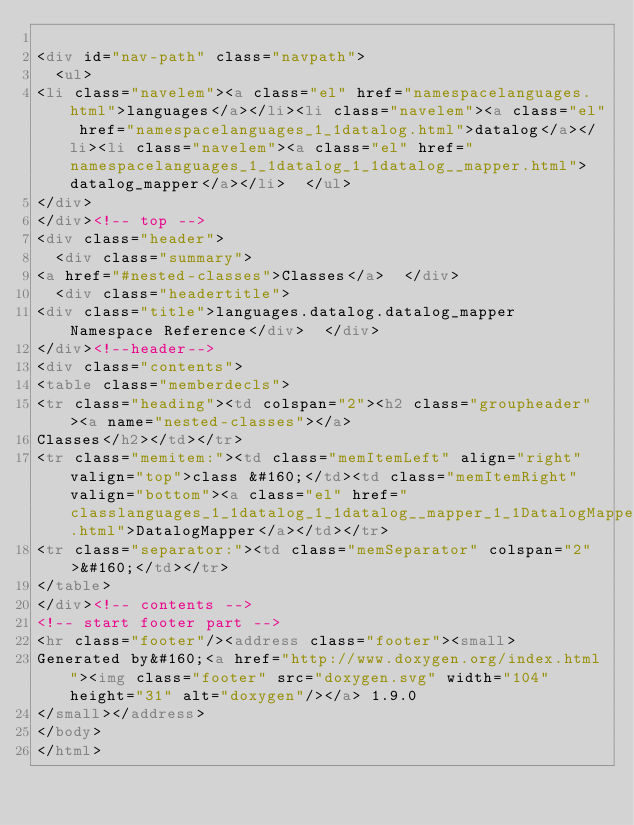<code> <loc_0><loc_0><loc_500><loc_500><_HTML_>
<div id="nav-path" class="navpath">
  <ul>
<li class="navelem"><a class="el" href="namespacelanguages.html">languages</a></li><li class="navelem"><a class="el" href="namespacelanguages_1_1datalog.html">datalog</a></li><li class="navelem"><a class="el" href="namespacelanguages_1_1datalog_1_1datalog__mapper.html">datalog_mapper</a></li>  </ul>
</div>
</div><!-- top -->
<div class="header">
  <div class="summary">
<a href="#nested-classes">Classes</a>  </div>
  <div class="headertitle">
<div class="title">languages.datalog.datalog_mapper Namespace Reference</div>  </div>
</div><!--header-->
<div class="contents">
<table class="memberdecls">
<tr class="heading"><td colspan="2"><h2 class="groupheader"><a name="nested-classes"></a>
Classes</h2></td></tr>
<tr class="memitem:"><td class="memItemLeft" align="right" valign="top">class &#160;</td><td class="memItemRight" valign="bottom"><a class="el" href="classlanguages_1_1datalog_1_1datalog__mapper_1_1DatalogMapper.html">DatalogMapper</a></td></tr>
<tr class="separator:"><td class="memSeparator" colspan="2">&#160;</td></tr>
</table>
</div><!-- contents -->
<!-- start footer part -->
<hr class="footer"/><address class="footer"><small>
Generated by&#160;<a href="http://www.doxygen.org/index.html"><img class="footer" src="doxygen.svg" width="104" height="31" alt="doxygen"/></a> 1.9.0
</small></address>
</body>
</html>
</code> 